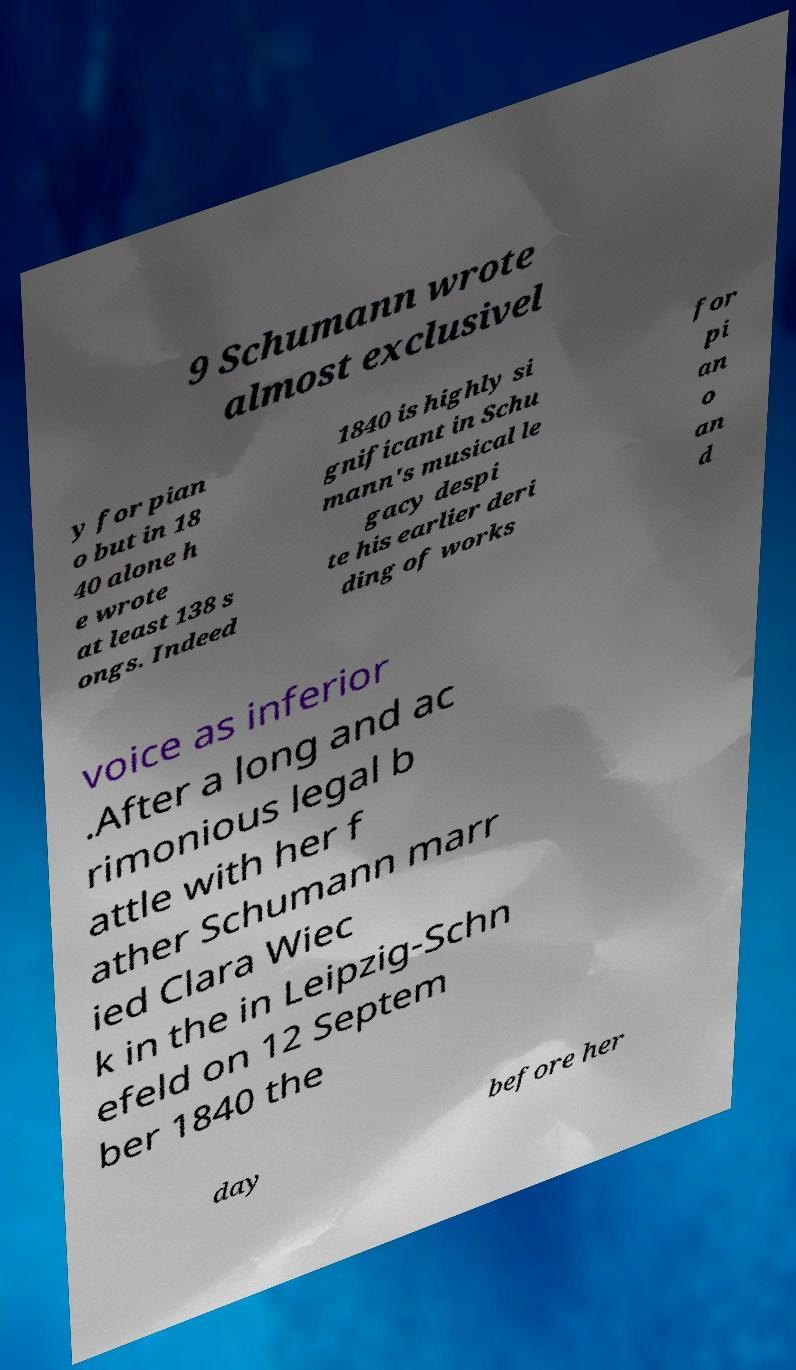There's text embedded in this image that I need extracted. Can you transcribe it verbatim? 9 Schumann wrote almost exclusivel y for pian o but in 18 40 alone h e wrote at least 138 s ongs. Indeed 1840 is highly si gnificant in Schu mann's musical le gacy despi te his earlier deri ding of works for pi an o an d voice as inferior .After a long and ac rimonious legal b attle with her f ather Schumann marr ied Clara Wiec k in the in Leipzig-Schn efeld on 12 Septem ber 1840 the day before her 